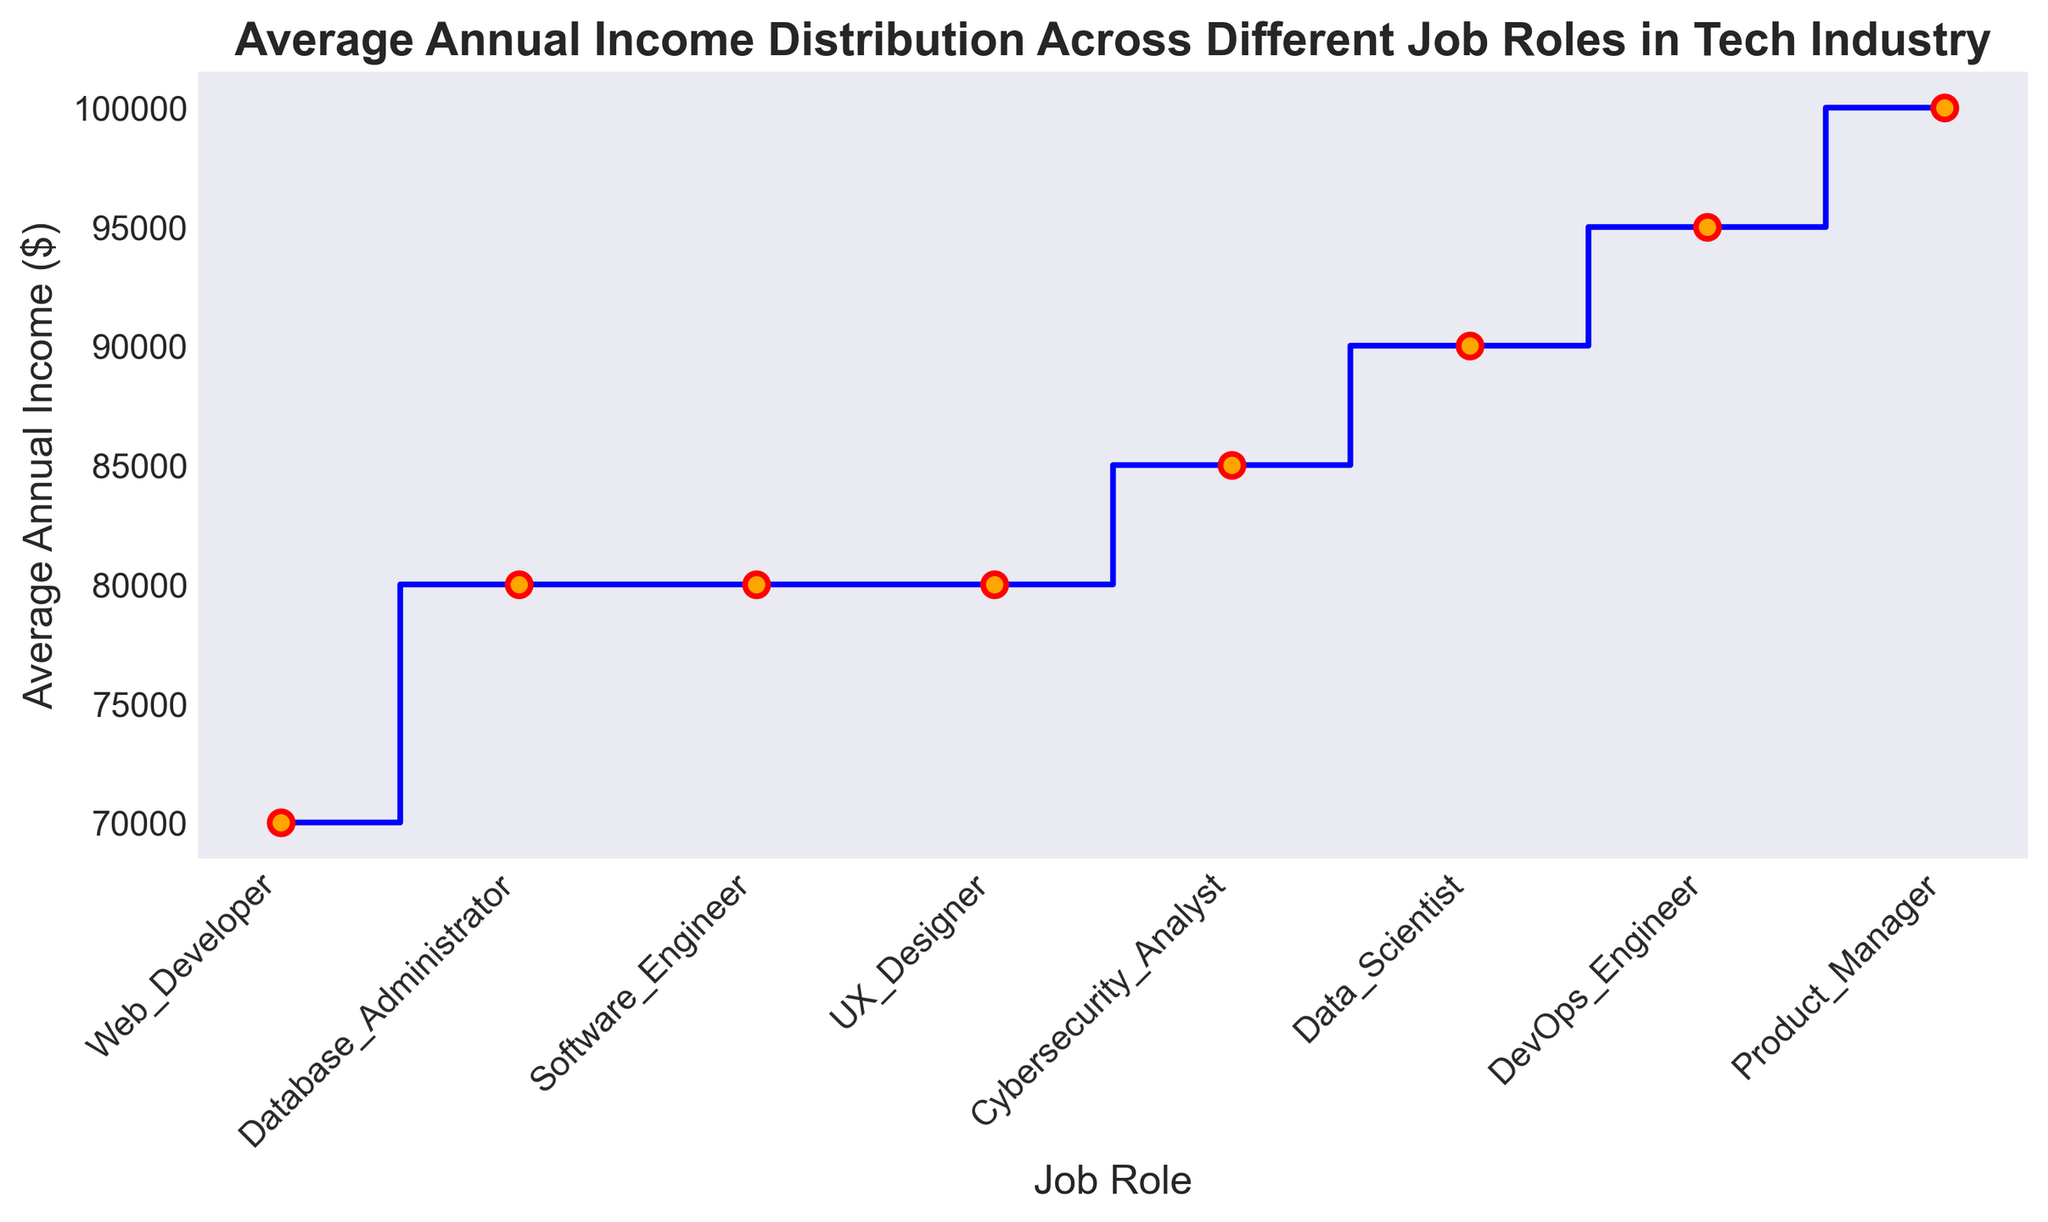Which job role has the highest average annual income? By observing the highest point on the y-axis, which corresponds to the x-axis label, the job role with the highest average annual income can be identified.
Answer: Product Manager Which job role has the lowest average annual income? By observing the lowest point on the y-axis, which corresponds to the x-axis label, the job role with the lowest average annual income can be identified.
Answer: Web Developer How does the average annual income of Software Engineers compare to Data Scientists? Compare the y-axis values corresponding to Software Engineers and Data Scientists on the x-axis to see which is higher.
Answer: Data Scientists have a higher average annual income What is the difference in average annual income between DevOps Engineers and Database Administrators? Find the y-axis values for both DevOps Engineers and Database Administrators using the x-axis labels, then subtract the latter from the former to get the difference.
Answer: $15,000 Which job role's average annual income is closest to $85,000? Look at the y-axis values around $85,000 and identify the closest job role by x-axis label.
Answer: DevOps Engineer Is the average annual income higher for UX Designers or Cybersecurity Analysts? Compare the y-axis values corresponding to UX Designers and Cybersecurity Analysts on the x-axis to see which is higher.
Answer: Cybersecurity Analyst What is the sum of the average annual incomes of Web Developers and Product Managers? Find the y-axis values for Web Developers and Product Managers, using their respective x-axis labels, and then add them together.
Answer: $170,000 If the average annual income of Data Scientists increases by $5,000, what will be the new average annual income? Add $5,000 to the current average annual income of Data Scientists by identifying their y-axis value.
Answer: $90,000 What visual feature indicates the sequence of average annual incomes across job roles? The step plot's line connects the points on the graph, showing a visual sequence from lowest to highest average annual incomes across job roles from left to right.
Answer: Step plot line 